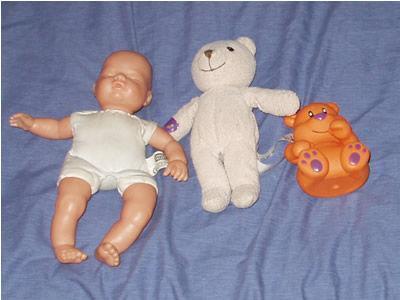How many teddy bears are in the photo?
Give a very brief answer. 2. 